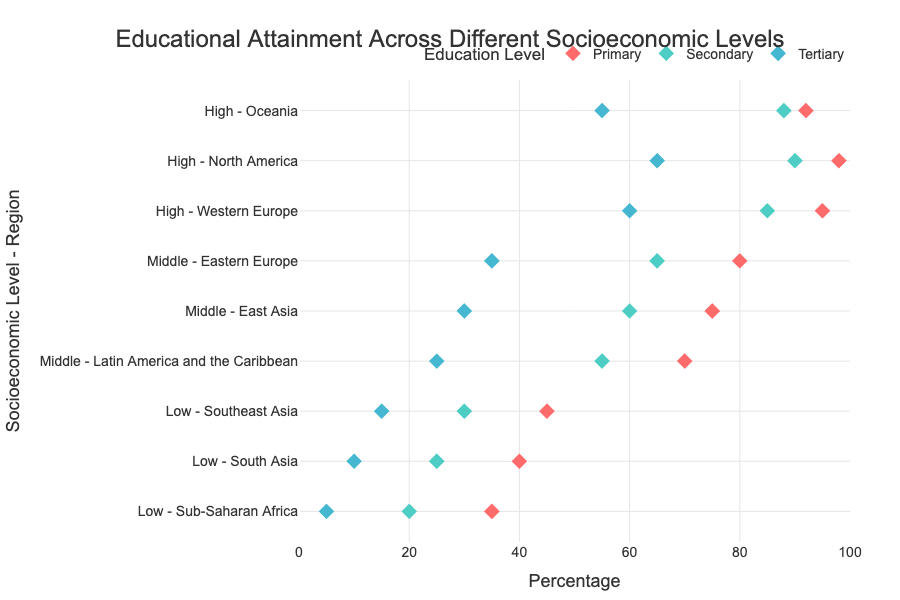What is the title of the plot? The title of the plot is always stated at the top of the figure. It reads "Educational Attainment Across Different Socioeconomic Levels."
Answer: Educational Attainment Across Different Socioeconomic Levels What are the educational attainment levels displayed in the plot? The three education levels are indicated by the legend and the labels next to the markers. These levels are 'Primary,' 'Secondary,' and 'Tertiary.'
Answer: Primary, Secondary, Tertiary Which region has the highest percentage of people with tertiary education among the 'Low' socioeconomic level? By comparing the tertiary education percentages for regions in the 'Low' socioeconomic level, we see that Southeast Asia has the highest percentage at 15%.
Answer: Southeast Asia In terms of secondary education, what is the difference in percentage points between North America and Sub-Saharan Africa? North America's percentage for secondary education is 90%, while Sub-Saharan Africa's percentage is 20%. Subtracting these values (90 - 20) gives a difference of 70 percentage points.
Answer: 70 percentage points What is the relationship between socioeconomic level and the percentage of people with primary education? Observing the dots for primary education across socioeconomic levels shows that the percentage generally increases as the socioeconomic level moves from 'Low' to 'High.' This suggests a positive correlation.
Answer: Positive correlation Which region within the 'Middle' socioeconomic level has the highest percentage of people with secondary education? Within the 'Middle' socioeconomic level, Eastern Europe has the highest percentage of people with secondary education at 65%.
Answer: Eastern Europe What is the average percentage of people with tertiary education in regions classified as 'High' socioeconomic level? For 'High' socioeconomic level, the percentages of tertiary education are 60% (Western Europe), 65% (North America), and 55% (Oceania). The average is calculated as (60 + 65 + 55) / 3, which equals 60%.
Answer: 60% How does the percentage of people with primary education in Sub-Saharan Africa compare to those with secondary education in Oceania? The plot shows that in Sub-Saharan Africa, 35% have primary education, whereas in Oceania, 88% have secondary education. Thus, the percentage is much lower in Sub-Saharan Africa when compared to secondary education in Oceania.
Answer: Much lower Which socioeconomic level and region combination has the lowest percentage of tertiary education, and what is that percentage? By looking at the dots representing tertiary education, we see that Sub-Saharan Africa in the 'Low' socioeconomic level has the lowest percentage at 5%.
Answer: Sub-Saharan Africa, 5% What is the percentage difference in primary education attainment between the region with the lowest percentage and the region with the highest percentage? The region with the lowest primary education percentage is Sub-Saharan Africa at 35%. The highest is North America at 98%. The percentage difference is 98 - 35 = 63 percentage points.
Answer: 63 percentage points 